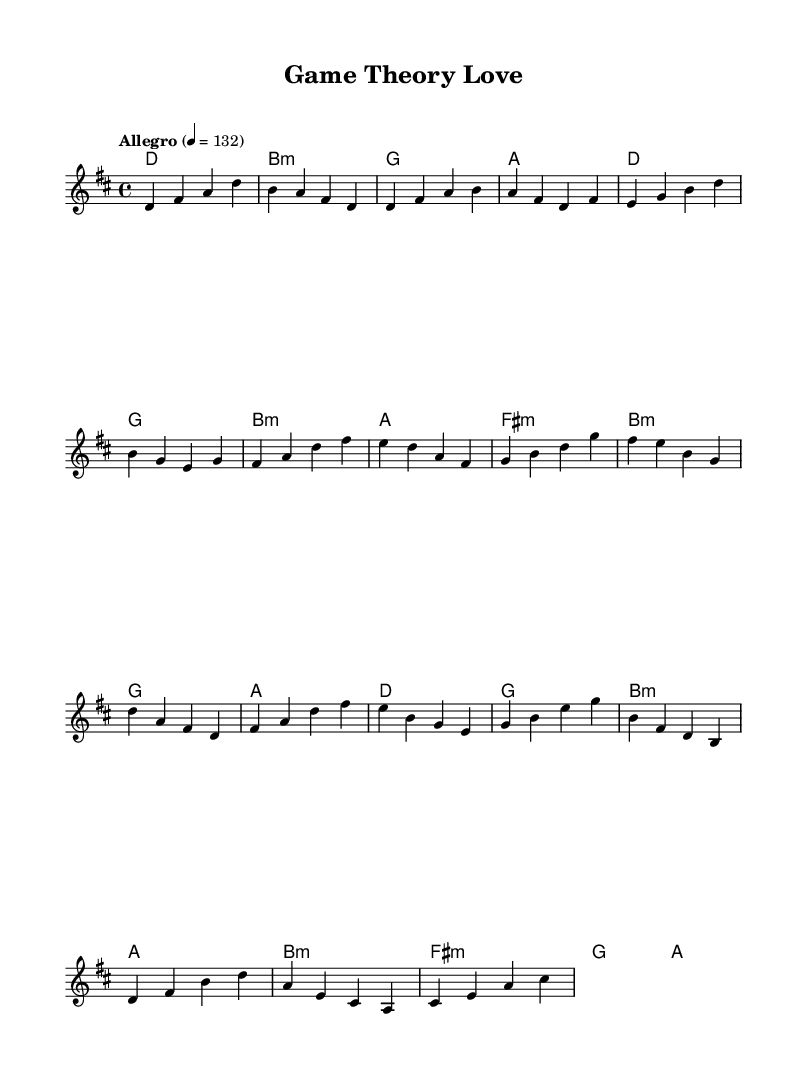What is the key signature of this music? The key signature is indicated at the beginning of the staff and consists of two sharps, which corresponds to the D major scale.
Answer: D major What is the time signature of this piece? The time signature is found at the beginning of the score as a fraction, and it shows there are four beats in each measure, making it 4/4.
Answer: 4/4 What is the tempo marking for this music? The tempo marking is written above the staff and indicates the speed of the piece, which is "Allegro," specifying a fast tempo of 132 beats per minute.
Answer: Allegro How many measures are present in the provided melody? By counting the number of vertical lines (bar lines) and noting the measures defined between them, the melody can be counted to have a total of 14 measures.
Answer: 14 What is the chord played during the chorus? The chorus section features the sequence of chords lined out in the chord mode, where the first chord played is D major.
Answer: D What is the relationship between the key signature and the first chord? The key signature indicates D major, and the first chord in the piece, as indicated, is also a D major chord, confirming they are in harmony.
Answer: Harmony Which section of the song has the highest note in the melody? By examining the melody line, the bridge section contains the note B, which is the highest pitch used, making it identifiable as the peak in the melody.
Answer: Bridge 